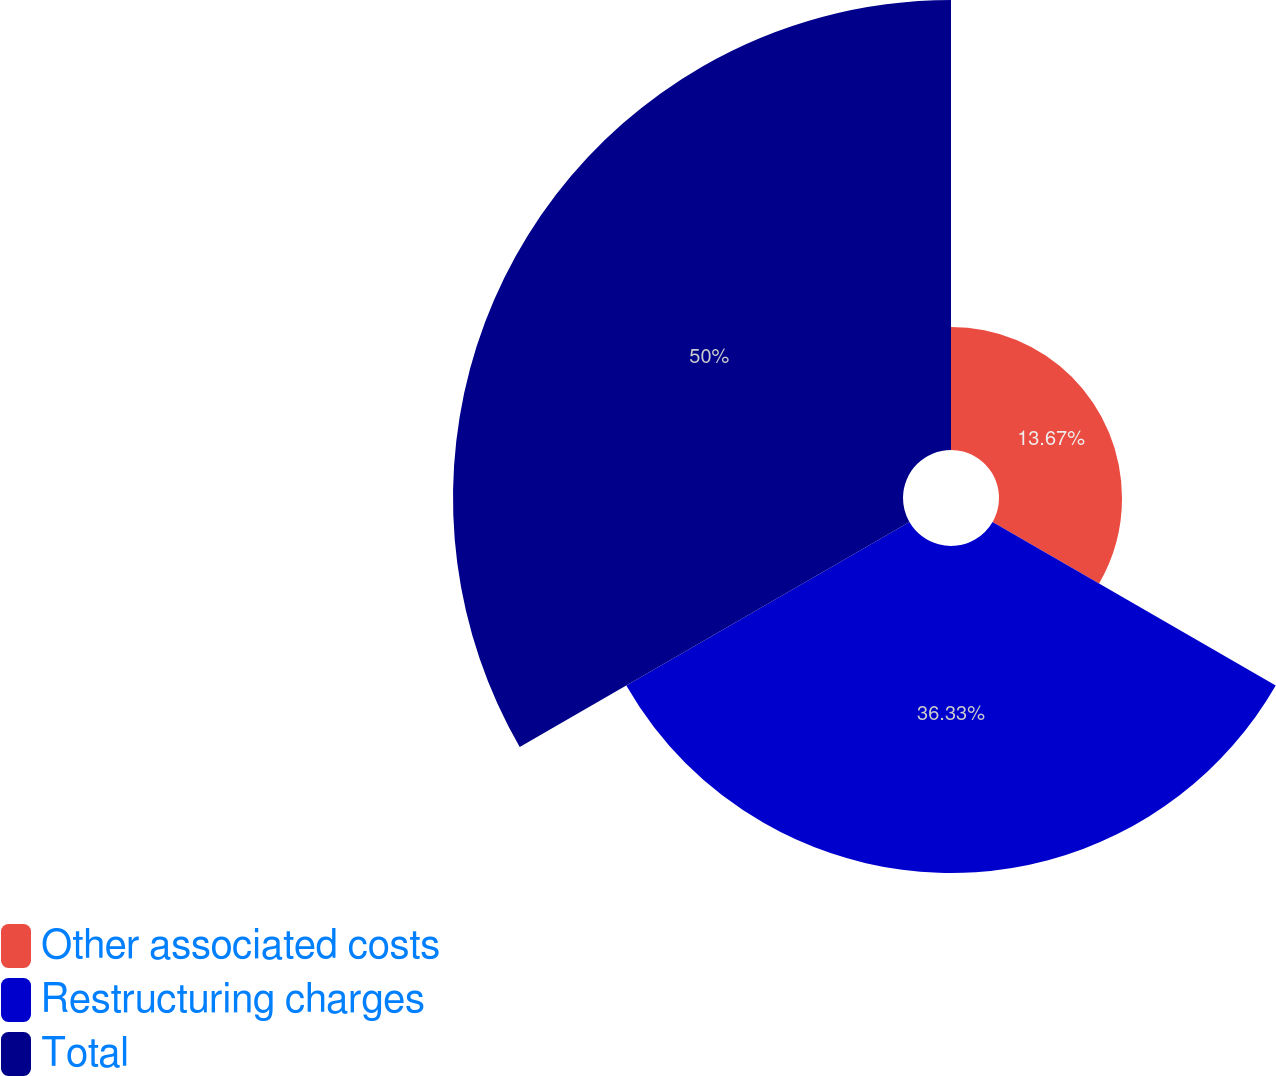Convert chart. <chart><loc_0><loc_0><loc_500><loc_500><pie_chart><fcel>Other associated costs<fcel>Restructuring charges<fcel>Total<nl><fcel>13.67%<fcel>36.33%<fcel>50.0%<nl></chart> 